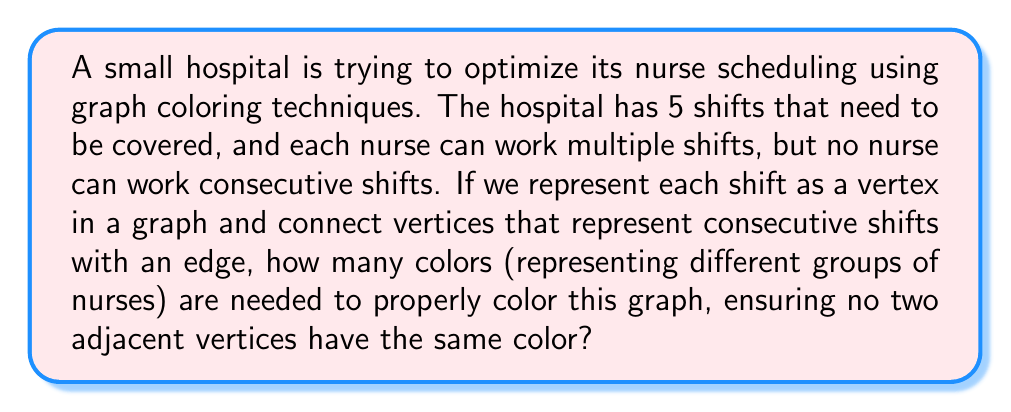Solve this math problem. To solve this problem, we'll follow these steps:

1) First, let's visualize the graph:

[asy]
unitsize(1cm);
pair A = (0,0), B = (2,0), C = (3,1), D = (2,2), E = (0,2);
draw(A--B--C--D--E--A);
draw(B--D);
draw(A--C);
label("1", A, SW);
label("2", B, SE);
label("3", C, E);
label("4", D, NE);
label("5", E, NW);
dot(A); dot(B); dot(C); dot(D); dot(E);
[/asy]

2) This graph represents the 5 shifts, where each vertex is a shift and edges connect consecutive shifts.

3) The problem of assigning nurses to shifts such that no nurse works consecutive shifts is equivalent to coloring this graph such that no adjacent vertices have the same color.

4) To determine the minimum number of colors needed, we need to find the chromatic number of this graph.

5) One way to determine the chromatic number is to look at the maximum clique size. A clique is a subset of vertices where every vertex is connected to every other vertex in the subset.

6) In this graph, the maximum clique size is 3. For example, vertices 1, 2, and 5 form a clique of size 3.

7) The chromatic number is always at least as large as the maximum clique size. So we need at least 3 colors.

8) We can actually color this graph with 3 colors:
   - Color 1: shifts 1 and 4
   - Color 2: shifts 2 and 5
   - Color 3: shift 3

9) This coloring ensures that no adjacent vertices (consecutive shifts) have the same color.

Therefore, the minimum number of colors needed is 3.
Answer: 3 colors 